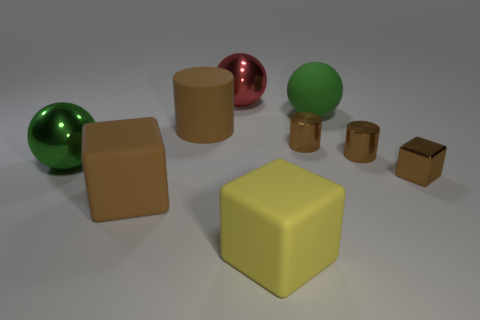Is the small brown block made of the same material as the big cylinder?
Your response must be concise. No. What is the shape of the large yellow thing?
Your answer should be compact. Cube. How many things are behind the yellow matte block that is to the left of the brown shiny thing on the left side of the green rubber object?
Ensure brevity in your answer.  8. The other large metal thing that is the same shape as the big green metallic thing is what color?
Offer a terse response. Red. There is a object that is behind the sphere that is on the right side of the large yellow thing that is in front of the big green metallic ball; what shape is it?
Ensure brevity in your answer.  Sphere. What size is the block that is both right of the red shiny object and behind the yellow cube?
Give a very brief answer. Small. Are there fewer brown matte cylinders than large purple metal cylinders?
Provide a short and direct response. No. What is the size of the brown cube that is to the right of the red shiny sphere?
Your response must be concise. Small. There is a rubber thing that is right of the big red thing and behind the yellow matte object; what is its shape?
Your response must be concise. Sphere. There is another rubber object that is the same shape as the yellow rubber thing; what size is it?
Provide a short and direct response. Large. 